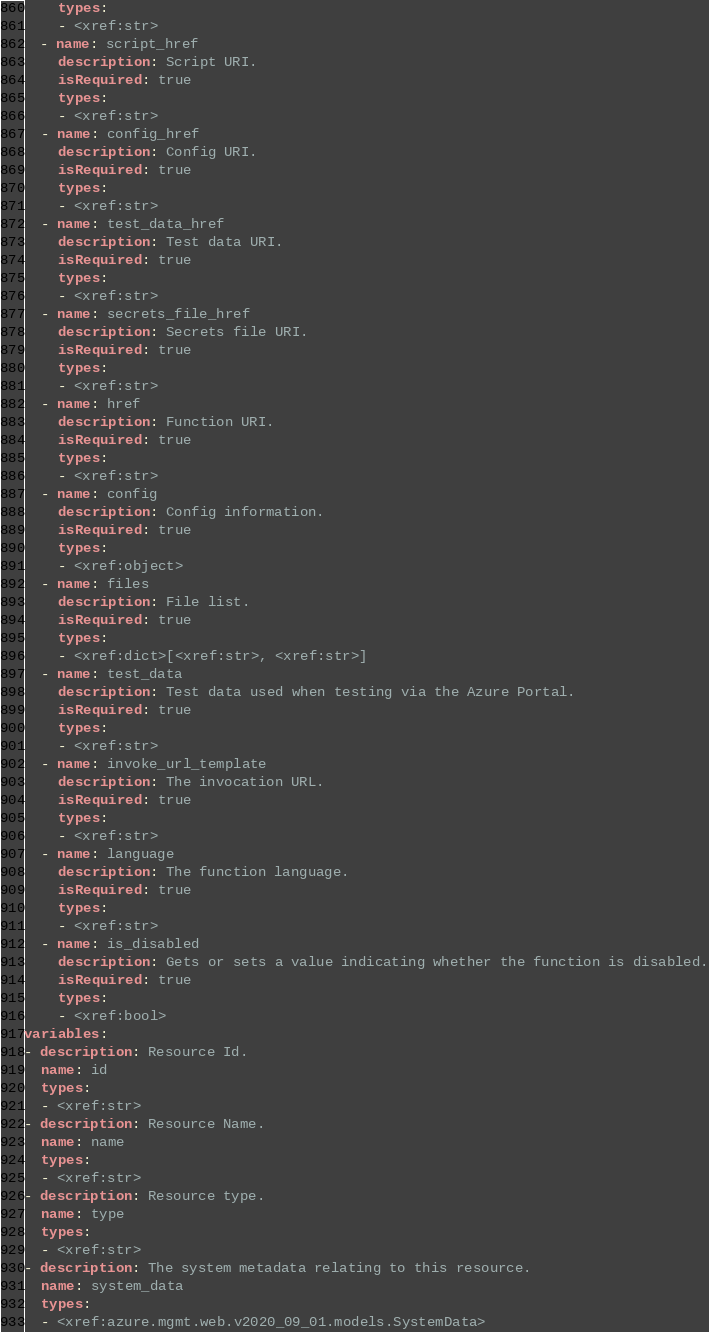Convert code to text. <code><loc_0><loc_0><loc_500><loc_500><_YAML_>    types:
    - <xref:str>
  - name: script_href
    description: Script URI.
    isRequired: true
    types:
    - <xref:str>
  - name: config_href
    description: Config URI.
    isRequired: true
    types:
    - <xref:str>
  - name: test_data_href
    description: Test data URI.
    isRequired: true
    types:
    - <xref:str>
  - name: secrets_file_href
    description: Secrets file URI.
    isRequired: true
    types:
    - <xref:str>
  - name: href
    description: Function URI.
    isRequired: true
    types:
    - <xref:str>
  - name: config
    description: Config information.
    isRequired: true
    types:
    - <xref:object>
  - name: files
    description: File list.
    isRequired: true
    types:
    - <xref:dict>[<xref:str>, <xref:str>]
  - name: test_data
    description: Test data used when testing via the Azure Portal.
    isRequired: true
    types:
    - <xref:str>
  - name: invoke_url_template
    description: The invocation URL.
    isRequired: true
    types:
    - <xref:str>
  - name: language
    description: The function language.
    isRequired: true
    types:
    - <xref:str>
  - name: is_disabled
    description: Gets or sets a value indicating whether the function is disabled.
    isRequired: true
    types:
    - <xref:bool>
variables:
- description: Resource Id.
  name: id
  types:
  - <xref:str>
- description: Resource Name.
  name: name
  types:
  - <xref:str>
- description: Resource type.
  name: type
  types:
  - <xref:str>
- description: The system metadata relating to this resource.
  name: system_data
  types:
  - <xref:azure.mgmt.web.v2020_09_01.models.SystemData>
</code> 